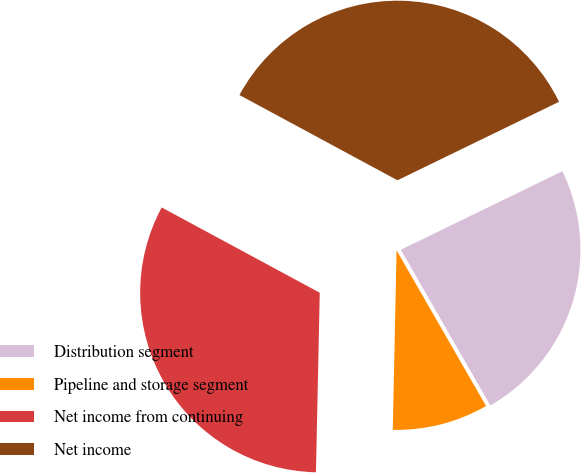<chart> <loc_0><loc_0><loc_500><loc_500><pie_chart><fcel>Distribution segment<fcel>Pipeline and storage segment<fcel>Net income from continuing<fcel>Net income<nl><fcel>23.9%<fcel>8.64%<fcel>32.54%<fcel>34.93%<nl></chart> 